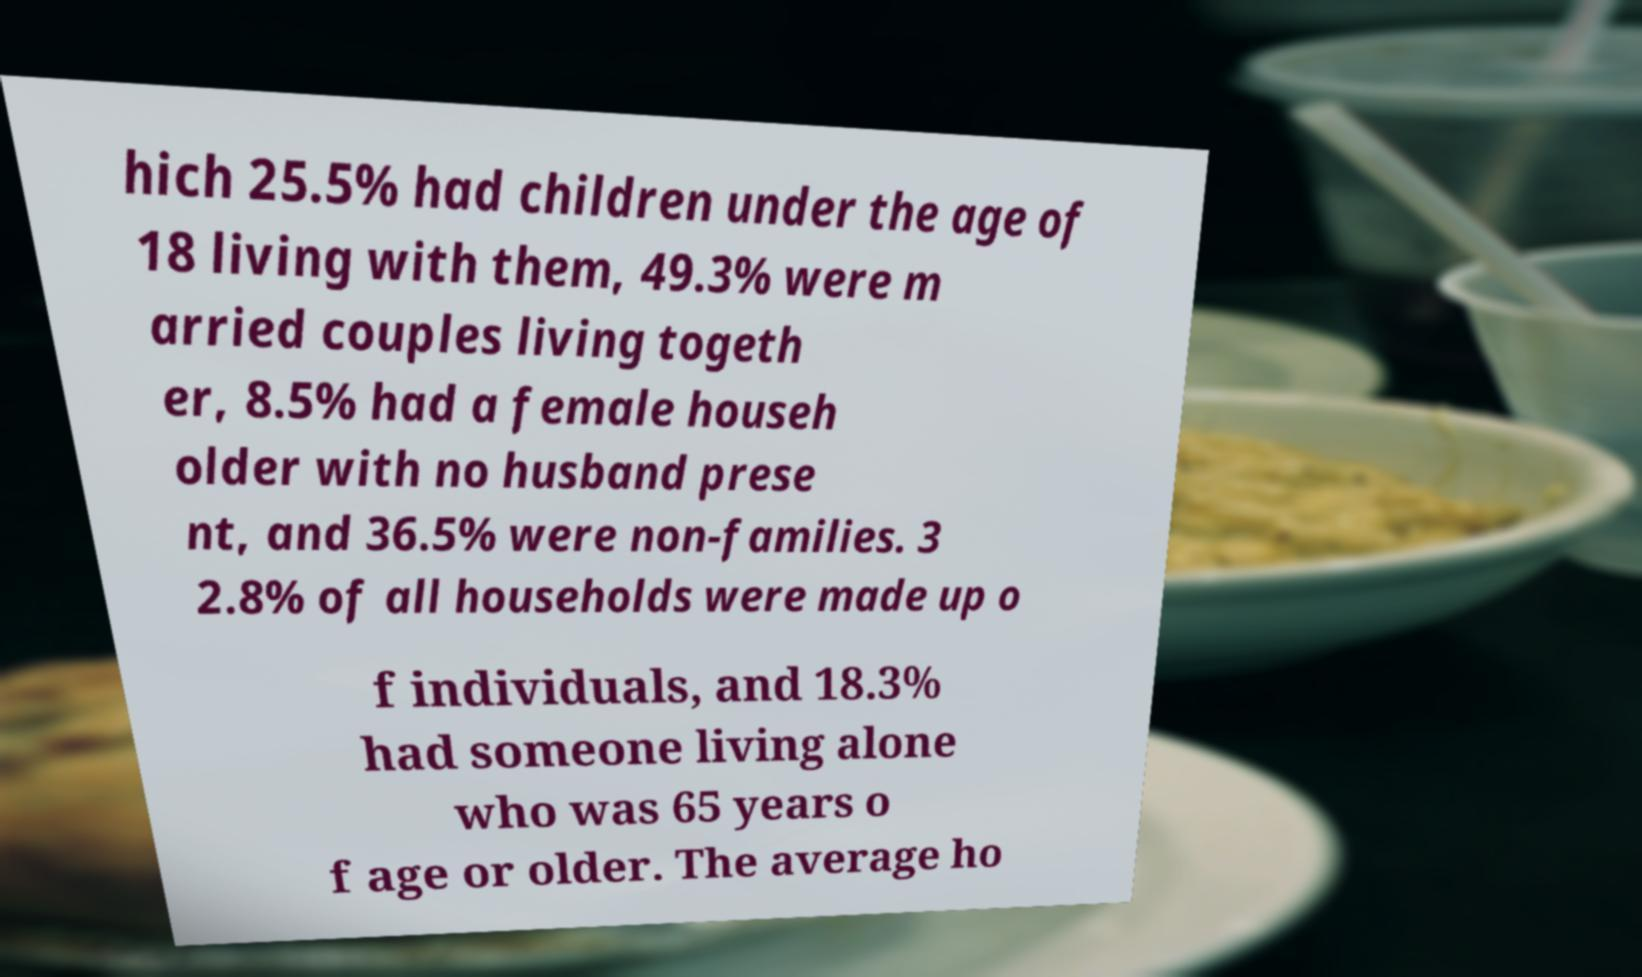Can you accurately transcribe the text from the provided image for me? hich 25.5% had children under the age of 18 living with them, 49.3% were m arried couples living togeth er, 8.5% had a female househ older with no husband prese nt, and 36.5% were non-families. 3 2.8% of all households were made up o f individuals, and 18.3% had someone living alone who was 65 years o f age or older. The average ho 